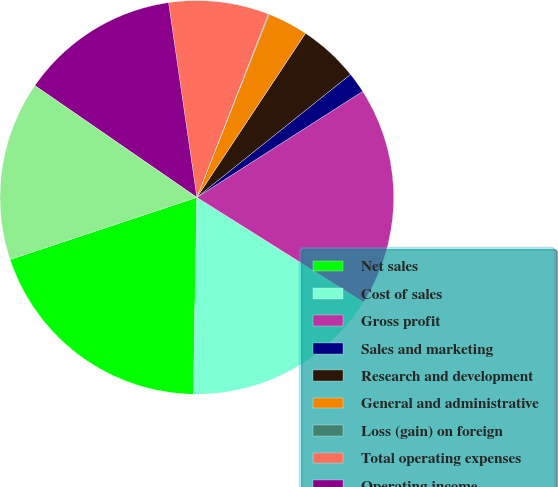<chart> <loc_0><loc_0><loc_500><loc_500><pie_chart><fcel>Net sales<fcel>Cost of sales<fcel>Gross profit<fcel>Sales and marketing<fcel>Research and development<fcel>General and administrative<fcel>Loss (gain) on foreign<fcel>Total operating expenses<fcel>Operating income<fcel>Income before provision for<nl><fcel>19.61%<fcel>16.35%<fcel>17.98%<fcel>1.69%<fcel>4.95%<fcel>3.32%<fcel>0.07%<fcel>8.21%<fcel>13.09%<fcel>14.72%<nl></chart> 